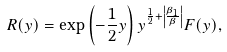<formula> <loc_0><loc_0><loc_500><loc_500>R ( y ) = \exp \left ( - \frac { 1 } { 2 } y \right ) y ^ { \frac { 1 } { 2 } + \left | \frac { \beta _ { 1 } } \beta \right | } F ( y ) ,</formula> 